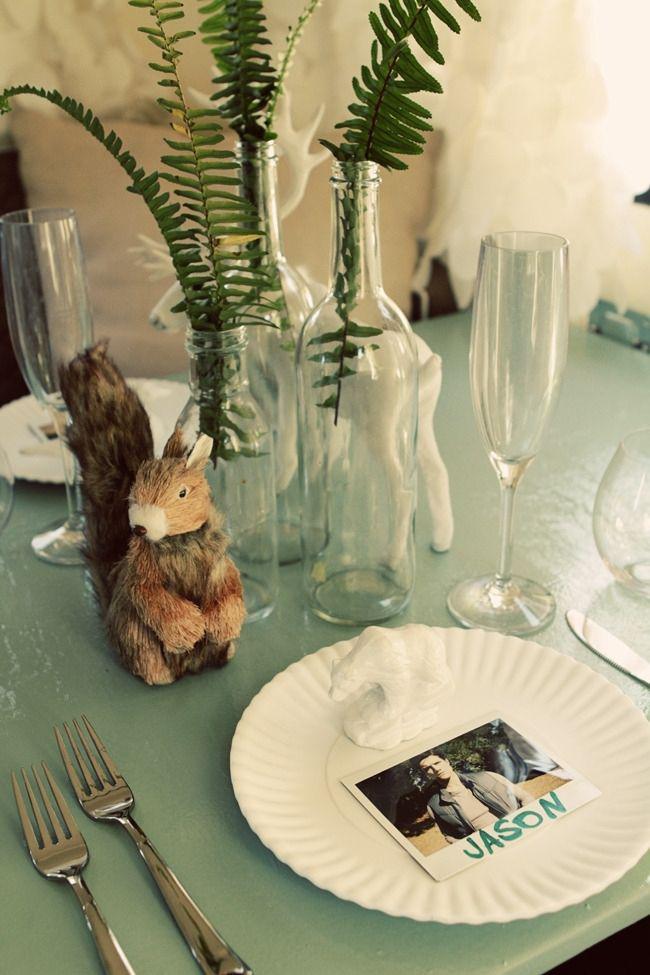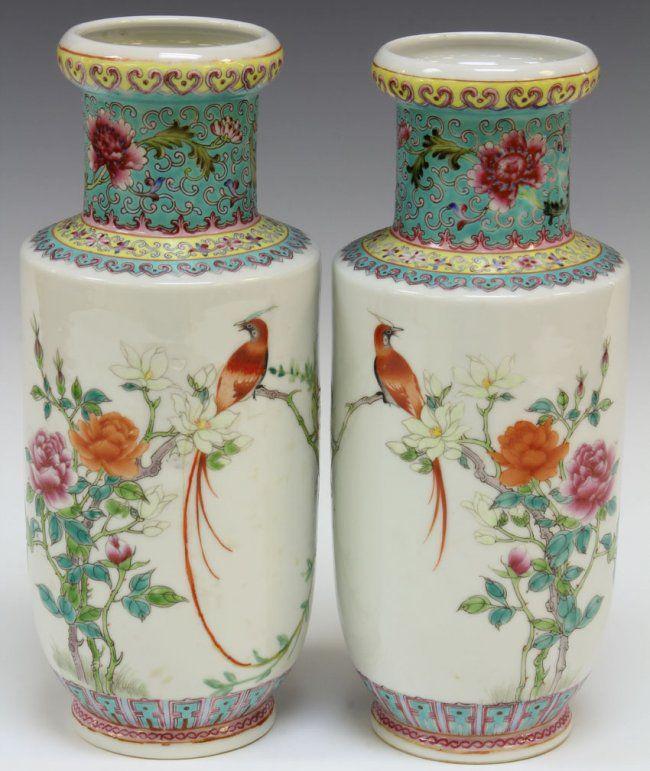The first image is the image on the left, the second image is the image on the right. For the images shown, is this caption "At least one vase appears bright blue." true? Answer yes or no. No. 